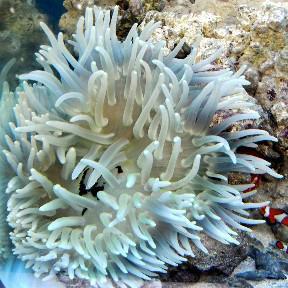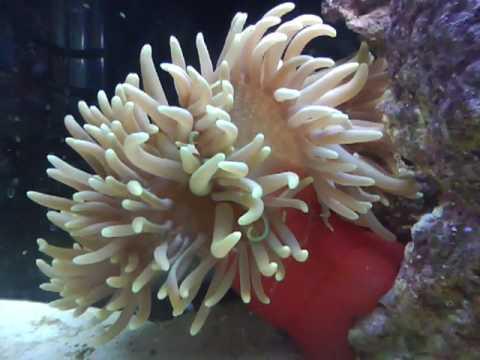The first image is the image on the left, the second image is the image on the right. Given the left and right images, does the statement "There is a white anemone in one of the images." hold true? Answer yes or no. Yes. 